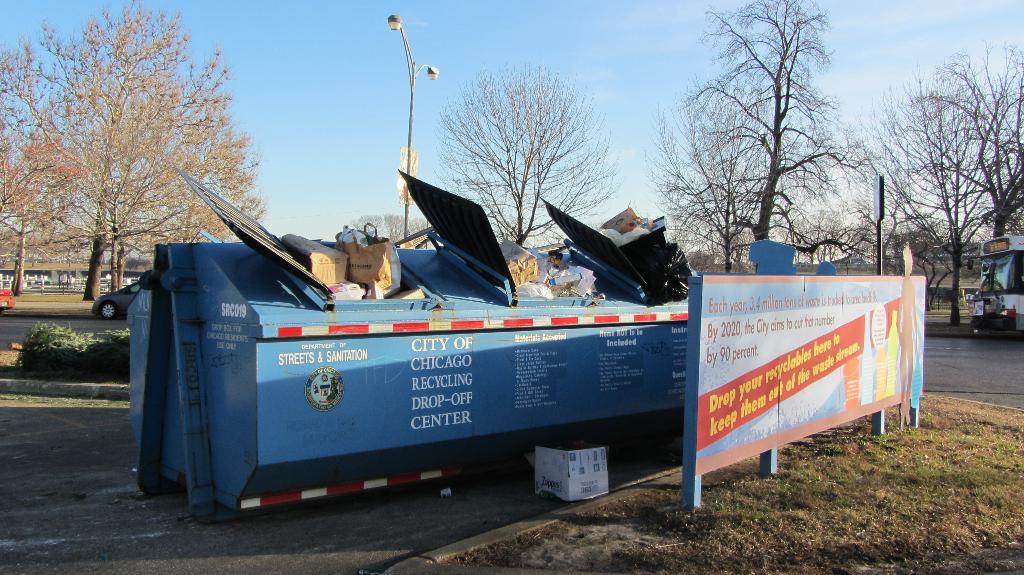What city is this?
Your answer should be very brief. Chicago. What is in the last row of text on the dumpster?
Provide a succinct answer. Center. 